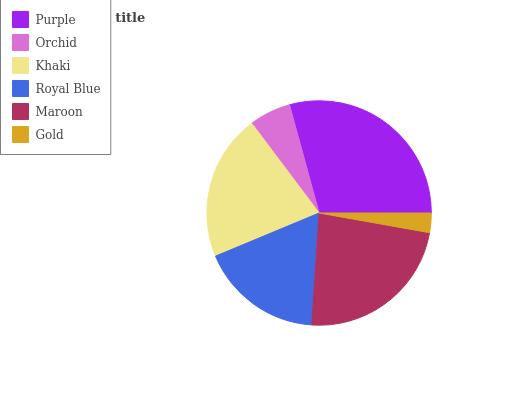Is Gold the minimum?
Answer yes or no. Yes. Is Purple the maximum?
Answer yes or no. Yes. Is Orchid the minimum?
Answer yes or no. No. Is Orchid the maximum?
Answer yes or no. No. Is Purple greater than Orchid?
Answer yes or no. Yes. Is Orchid less than Purple?
Answer yes or no. Yes. Is Orchid greater than Purple?
Answer yes or no. No. Is Purple less than Orchid?
Answer yes or no. No. Is Khaki the high median?
Answer yes or no. Yes. Is Royal Blue the low median?
Answer yes or no. Yes. Is Royal Blue the high median?
Answer yes or no. No. Is Maroon the low median?
Answer yes or no. No. 